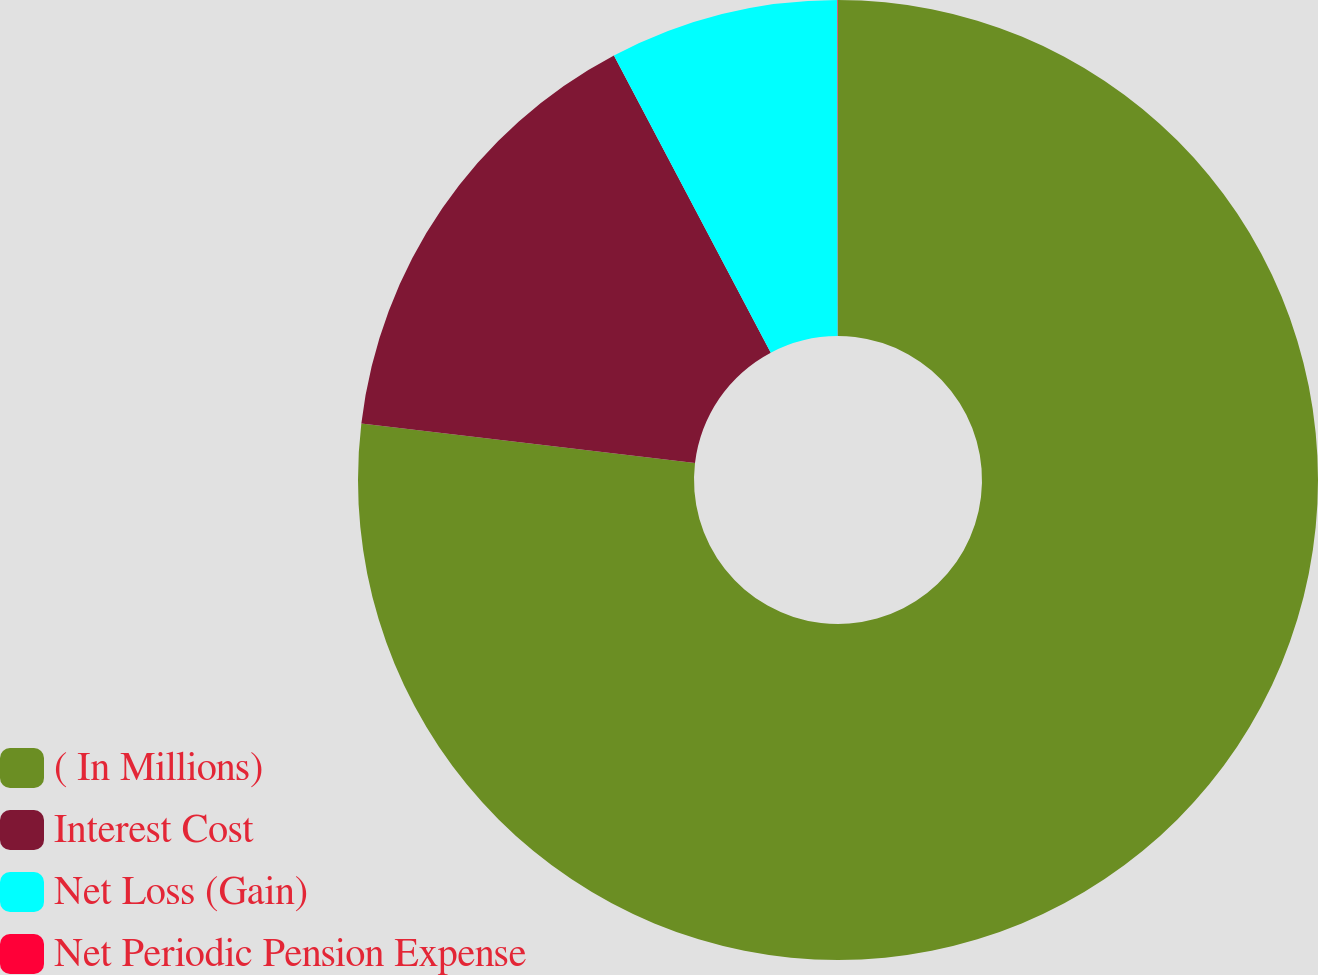Convert chart. <chart><loc_0><loc_0><loc_500><loc_500><pie_chart><fcel>( In Millions)<fcel>Interest Cost<fcel>Net Loss (Gain)<fcel>Net Periodic Pension Expense<nl><fcel>76.88%<fcel>15.39%<fcel>7.71%<fcel>0.02%<nl></chart> 